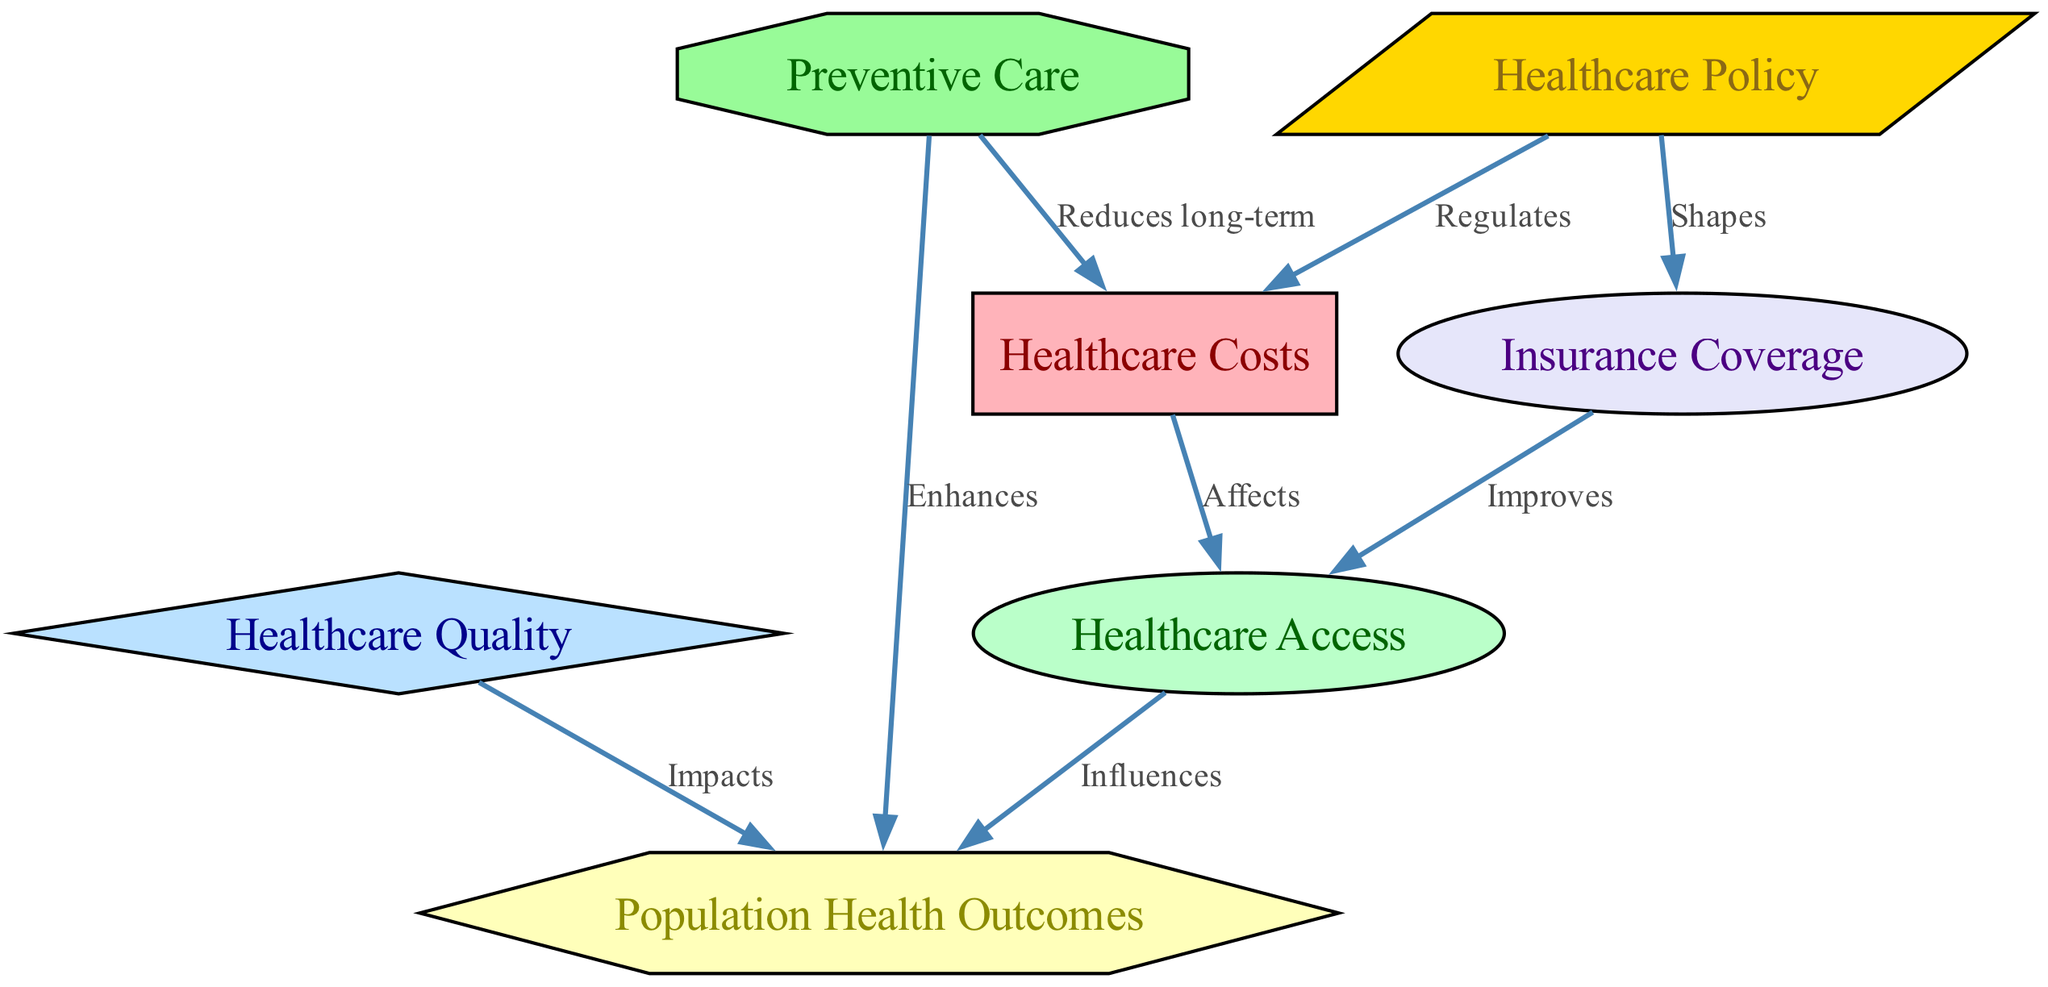What is the total number of nodes in the diagram? The diagram contains nodes for healthcare costs, access, quality, health outcomes, policy, insurance, and prevention. Counting these gives a total of seven nodes.
Answer: 7 Which node has the shape of a diamond? In the node classifications, the node labeled "Quality" is the only one explicitly designated with a diamond shape as per the diagram.
Answer: Quality What is the relationship between healthcare access and population health outcomes? The diagram shows that healthcare access influences population health outcomes, as indicated by the directed edge connecting these two nodes.
Answer: Influences Which node regulates healthcare costs? The diagram indicates that "Healthcare Policy" has a direct regulatory effect on "Healthcare Costs" as seen in the directed edge between the two nodes.
Answer: Healthcare Policy How does preventive care affect healthcare costs? The directed edge from "Prevention" to "Healthcare Costs" clearly states that preventive care reduces long-term healthcare costs, highlighting an inverse relationship.
Answer: Reduces long-term What is the flow of influence from policy to access? According to the diagram, "Healthcare Policy" shapes "Insurance Coverage," and then "Insurance Coverage" improves "Healthcare Access." This shows a sequential flow of influence through these nodes.
Answer: Shapes → Improves Which node has a hexagonal shape? The node labeled "Population Health Outcomes" is depicted as a hexagon, distinguishing it from other node shapes in the diagram.
Answer: Population Health Outcomes What is the impact of quality on health outcomes? The diagram indicates that quality impacts health outcomes, evidenced by the directed edge from the quality node to the health outcomes node.
Answer: Impacts How many edges are present in the diagram? By examining the connections drawn between nodes, it can be counted that there are a total of eight directed edges in the diagram.
Answer: 8 